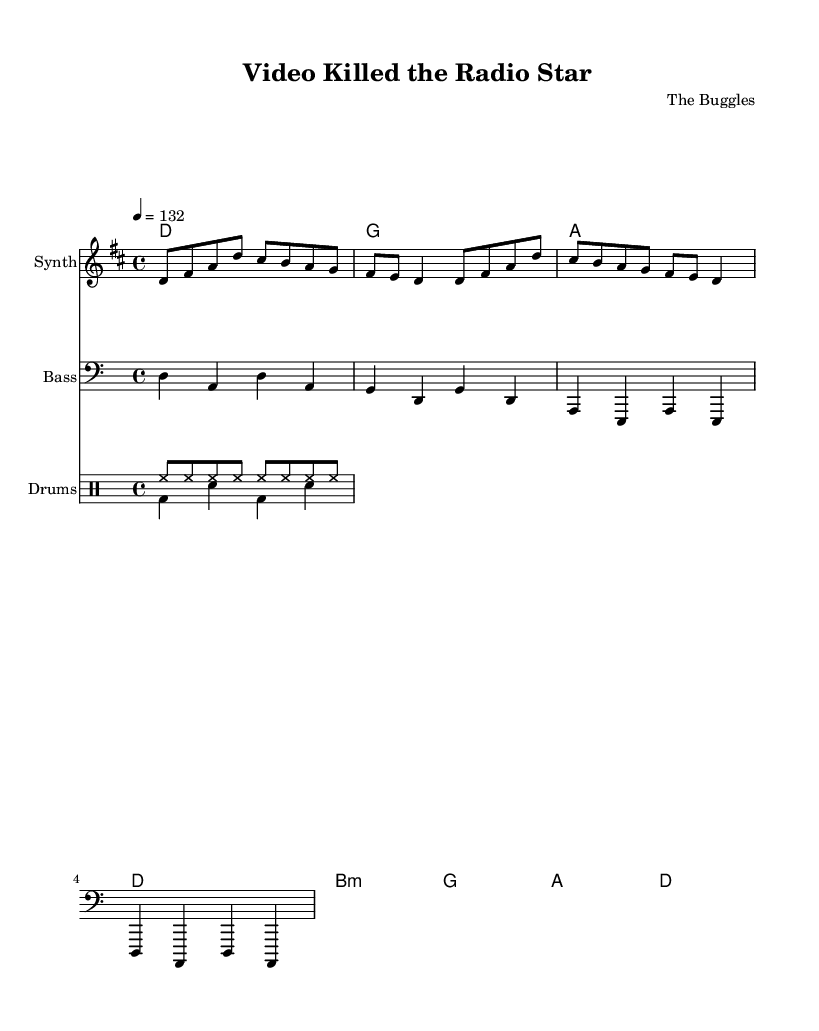What is the key signature of this music? The key signature is D major, which contains two sharps (F# and C#). This is indicated by the key signature at the beginning of the score.
Answer: D major What is the time signature of this music? The time signature is 4/4, which is noted at the beginning of the score. This means there are four beats in each measure, and each beat is a quarter note.
Answer: 4/4 What is the tempo of the piece? The tempo marking indicates a speed of 132 beats per minute, which is written in the score alongside the tempo indication.
Answer: 132 How many chords are there in the harmony section? The harmony section contains 4 chords, which can be counted by identifying each chord notation in the chord mode.
Answer: 4 How does the bass line interact with the melody? The bass line provides a foundational rhythm and pitches that often align with the harmony and support the melody, complementing its higher range with lower notes. This creates fullness in the arrangement typical of synthpop.
Answer: Complementary What rhythmic pattern is used for the drums? The drum pattern consists of a consistent hi-hat pattern and an alternating bass and snare rhythm, common in electronic music to add energy and drive to the track.
Answer: Hi-hat and snare pattern What genre is this track associated with? This track is associated with synthpop, as it features synthesizers prominently in the melody, which defines the genre's sound during the 1980s.
Answer: Synthpop 